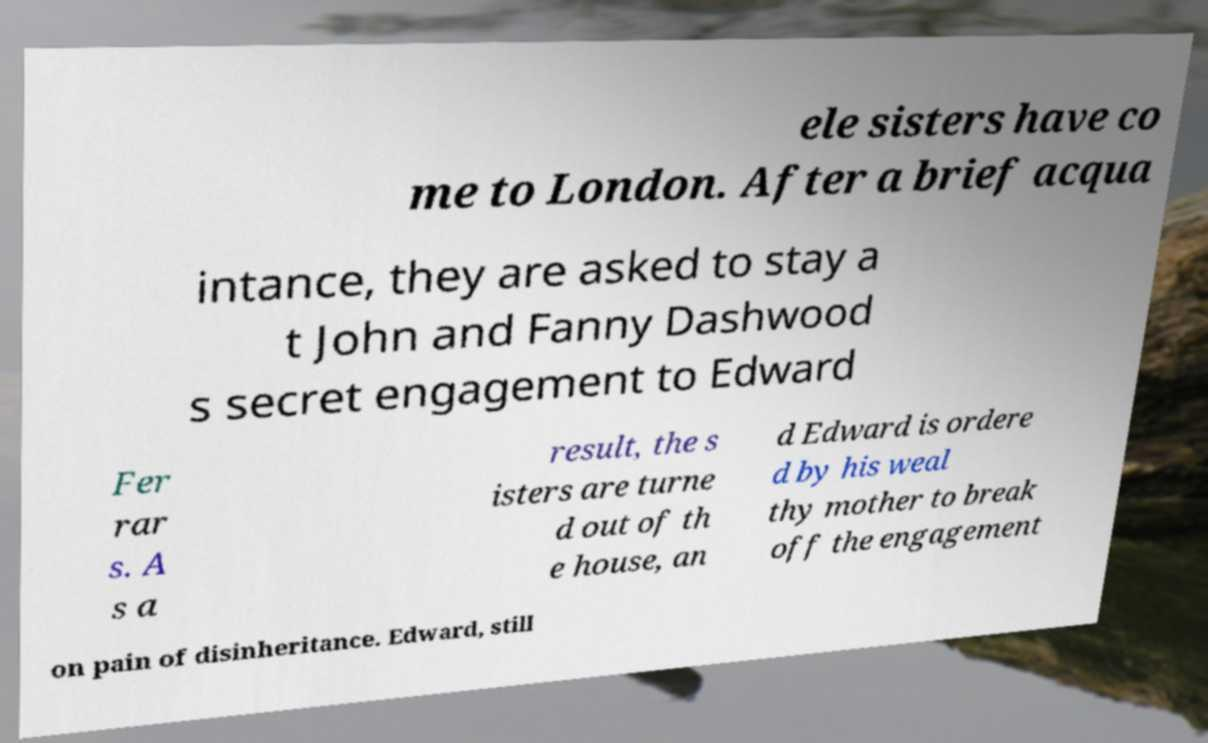There's text embedded in this image that I need extracted. Can you transcribe it verbatim? ele sisters have co me to London. After a brief acqua intance, they are asked to stay a t John and Fanny Dashwood s secret engagement to Edward Fer rar s. A s a result, the s isters are turne d out of th e house, an d Edward is ordere d by his weal thy mother to break off the engagement on pain of disinheritance. Edward, still 